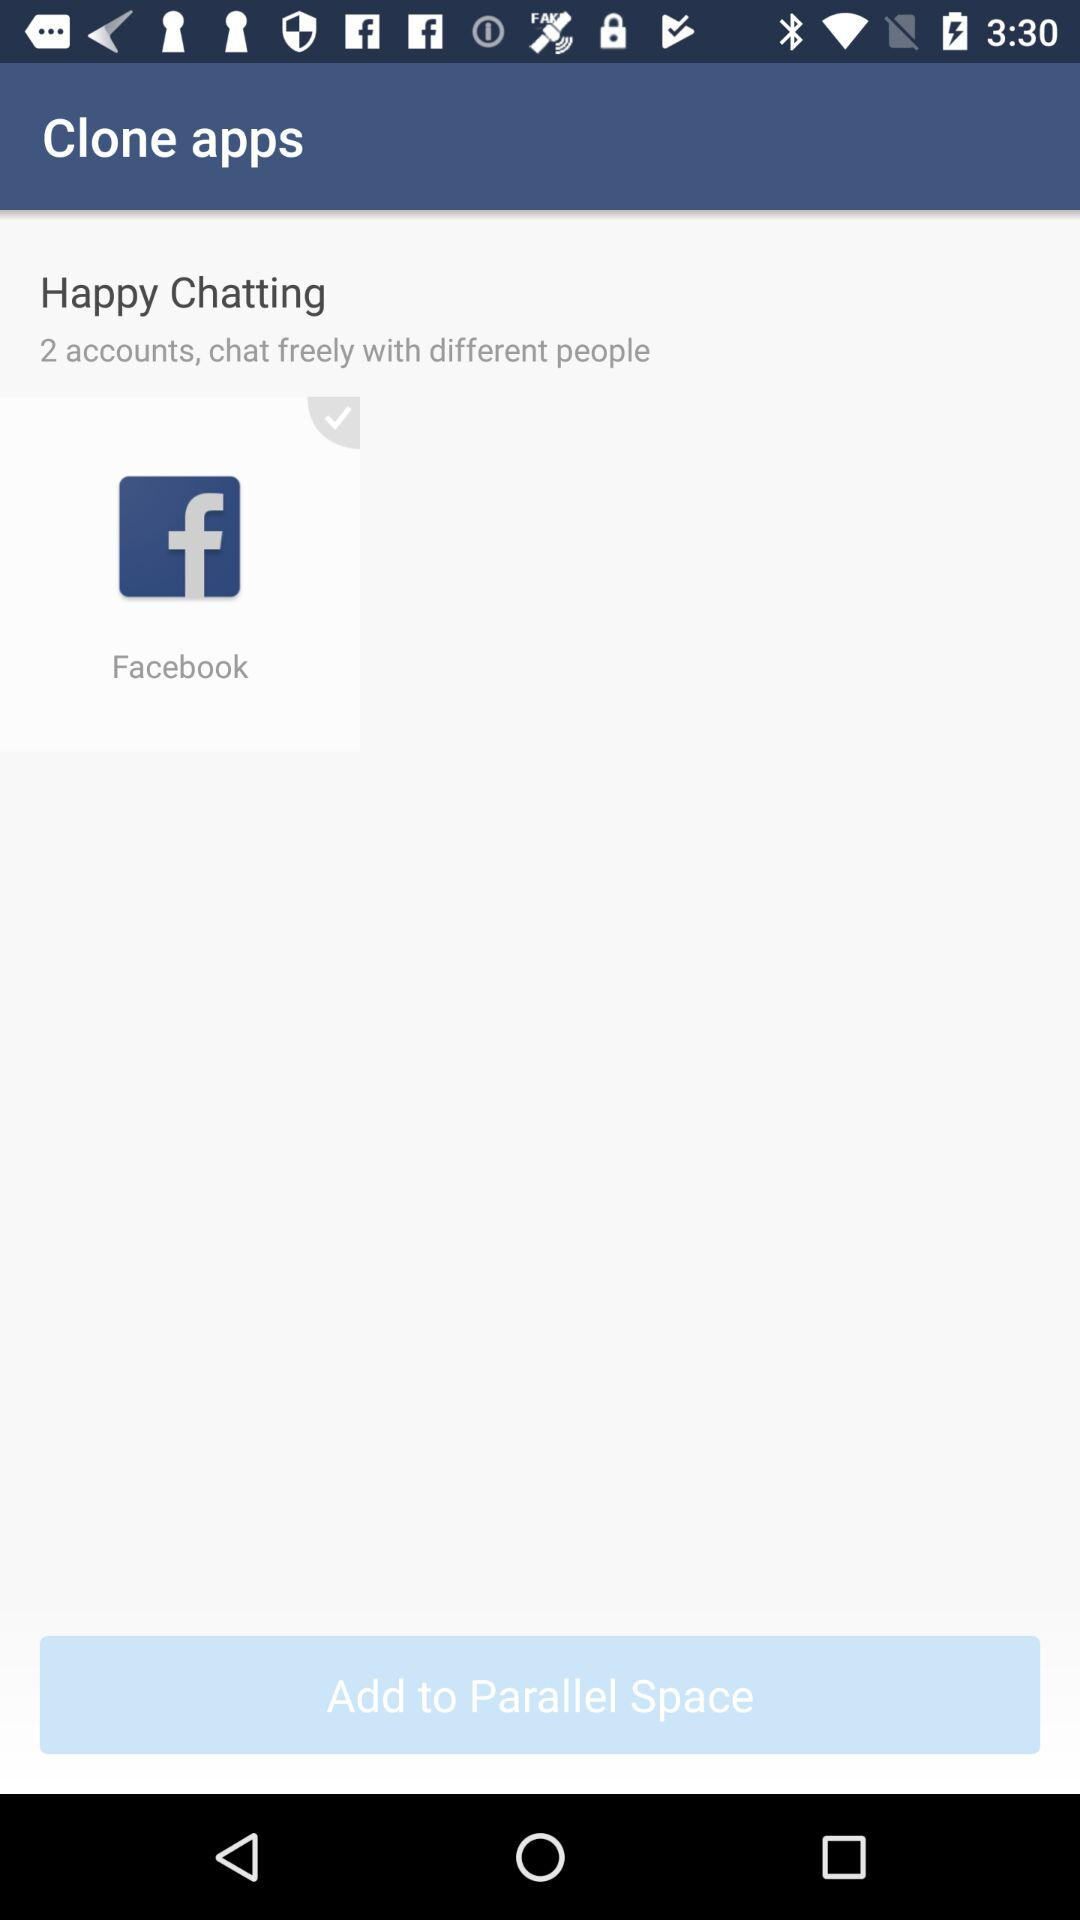What's the selected application? The selected application is "Facebook". 